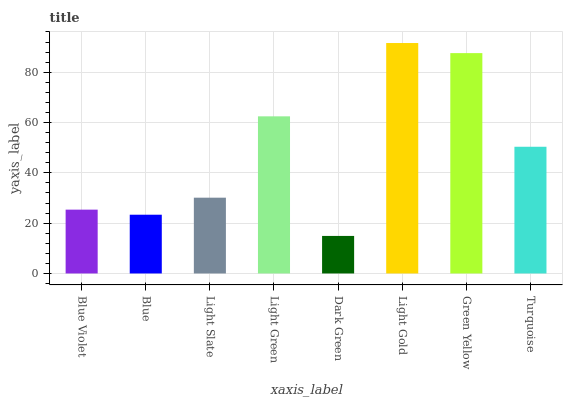Is Dark Green the minimum?
Answer yes or no. Yes. Is Light Gold the maximum?
Answer yes or no. Yes. Is Blue the minimum?
Answer yes or no. No. Is Blue the maximum?
Answer yes or no. No. Is Blue Violet greater than Blue?
Answer yes or no. Yes. Is Blue less than Blue Violet?
Answer yes or no. Yes. Is Blue greater than Blue Violet?
Answer yes or no. No. Is Blue Violet less than Blue?
Answer yes or no. No. Is Turquoise the high median?
Answer yes or no. Yes. Is Light Slate the low median?
Answer yes or no. Yes. Is Light Gold the high median?
Answer yes or no. No. Is Dark Green the low median?
Answer yes or no. No. 